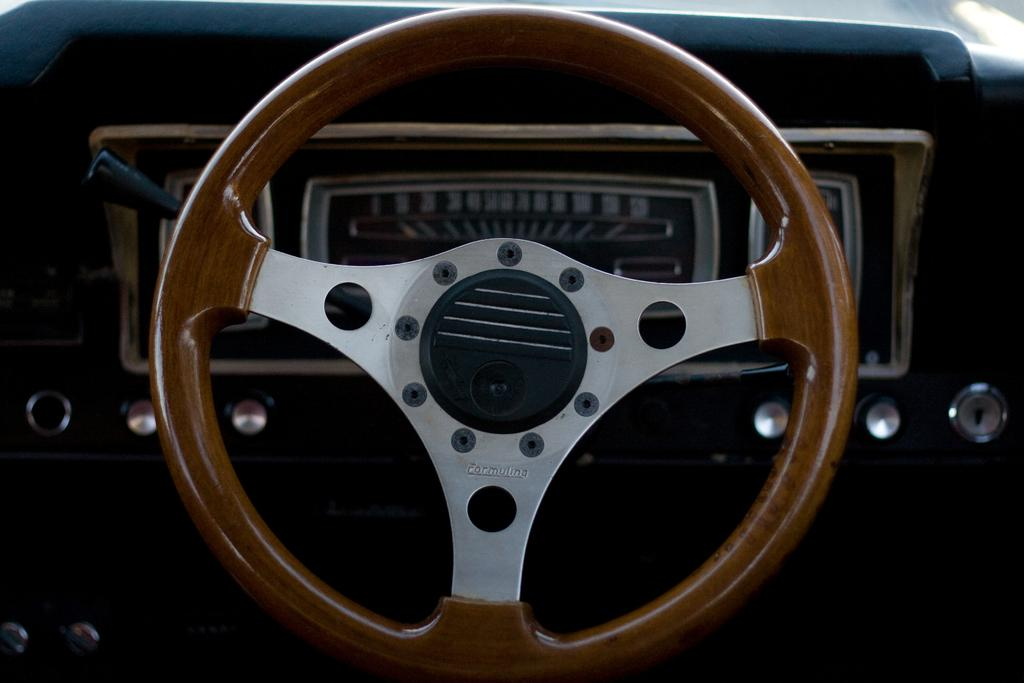What type of location is depicted in the image? The image is an inside view of a vehicle. What is the main control device in the vehicle? There is a steering wheel in the image. How can the driver monitor their speed in the vehicle? There is a speedometer in the image. What other items can be seen in the vehicle? There are other objects visible in the image. How many spoons are visible in the image? There are no spoons present in the image, as it depicts an inside view of a vehicle. 